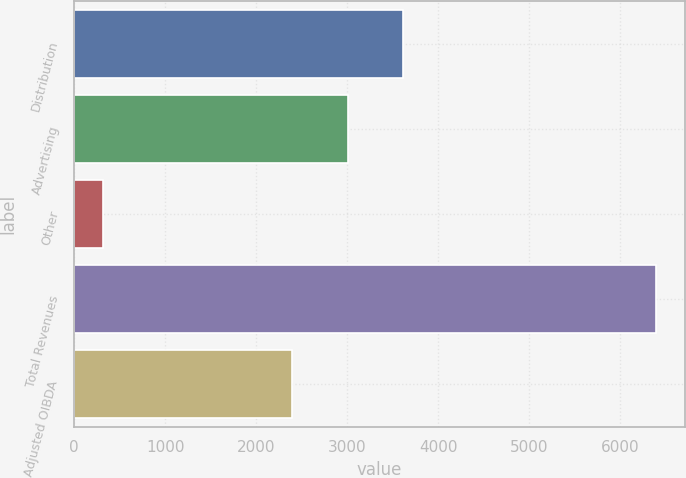Convert chart. <chart><loc_0><loc_0><loc_500><loc_500><bar_chart><fcel>Distribution<fcel>Advertising<fcel>Other<fcel>Total Revenues<fcel>Adjusted OIBDA<nl><fcel>3612.4<fcel>3005.2<fcel>322<fcel>6394<fcel>2398<nl></chart> 